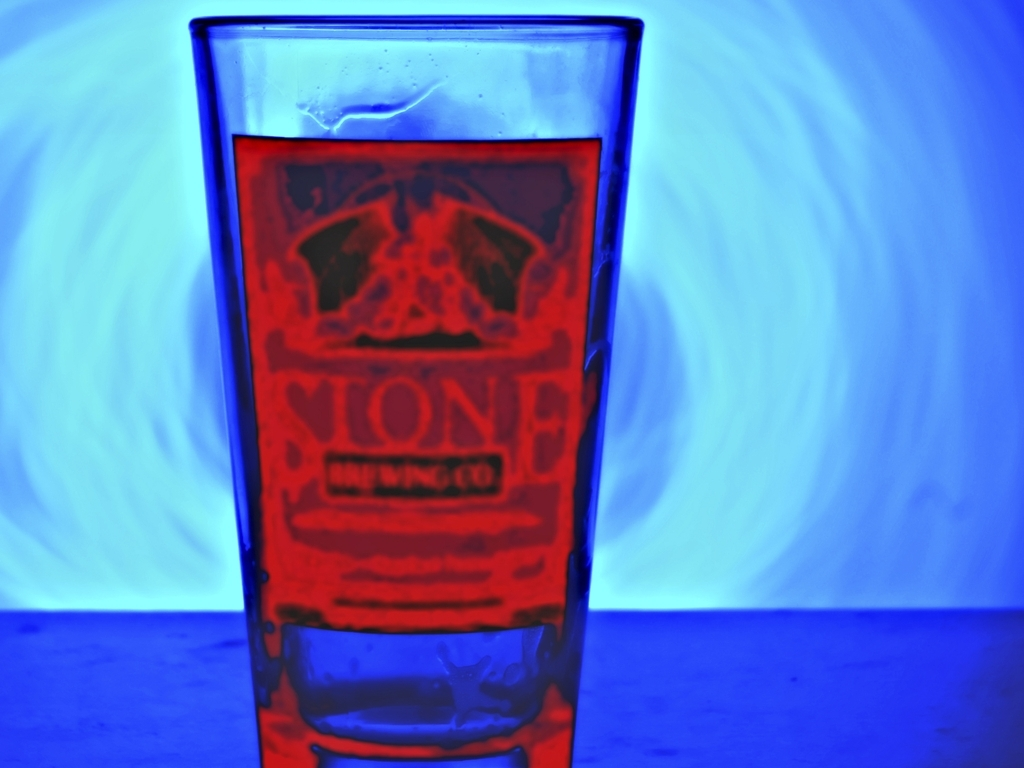Can you describe the aesthetic conveyed by the combination of colors in this image? The image exhibits a fascinating mix of warm and cool tones. The glass, emblazoned with red text, stands out against the cool blue backdrop, creating a striking contrast. This interplay suggests a vibe that is both energetic and serene, reminiscent of modern or artistic settings where color contrast is used to draw the viewer's eye and evoke a sense of dynamic vibrancy. 